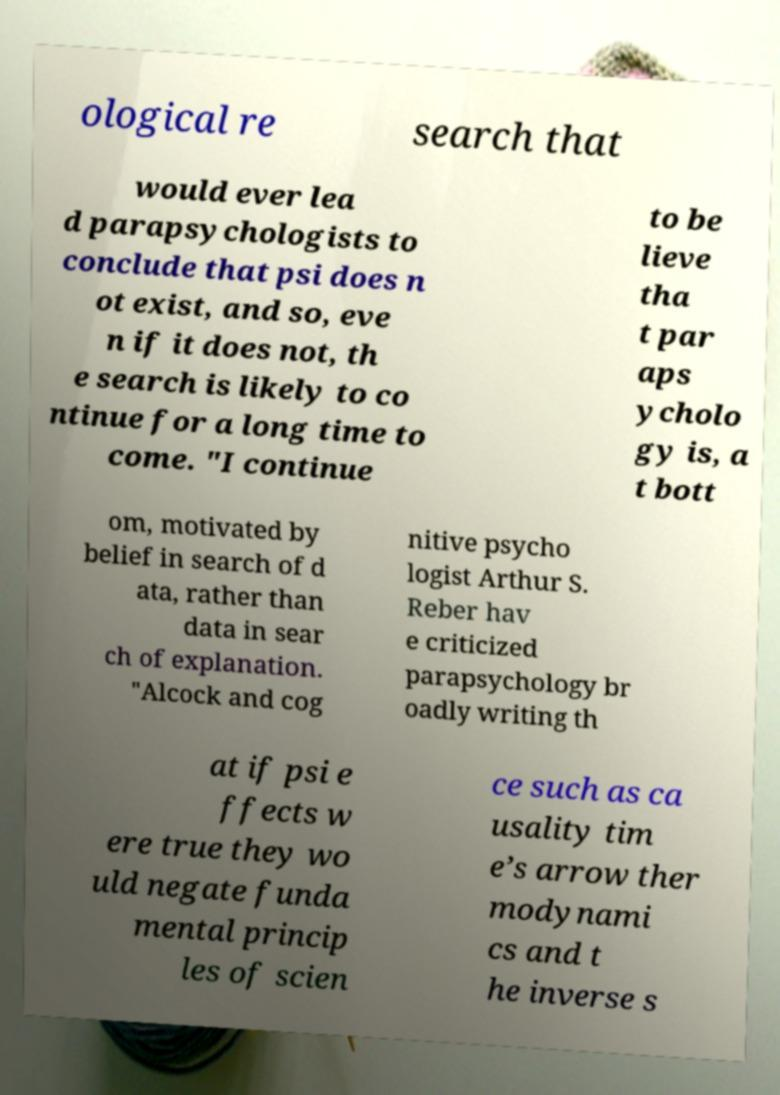Can you accurately transcribe the text from the provided image for me? ological re search that would ever lea d parapsychologists to conclude that psi does n ot exist, and so, eve n if it does not, th e search is likely to co ntinue for a long time to come. "I continue to be lieve tha t par aps ycholo gy is, a t bott om, motivated by belief in search of d ata, rather than data in sear ch of explanation. "Alcock and cog nitive psycho logist Arthur S. Reber hav e criticized parapsychology br oadly writing th at if psi e ffects w ere true they wo uld negate funda mental princip les of scien ce such as ca usality tim e’s arrow ther modynami cs and t he inverse s 